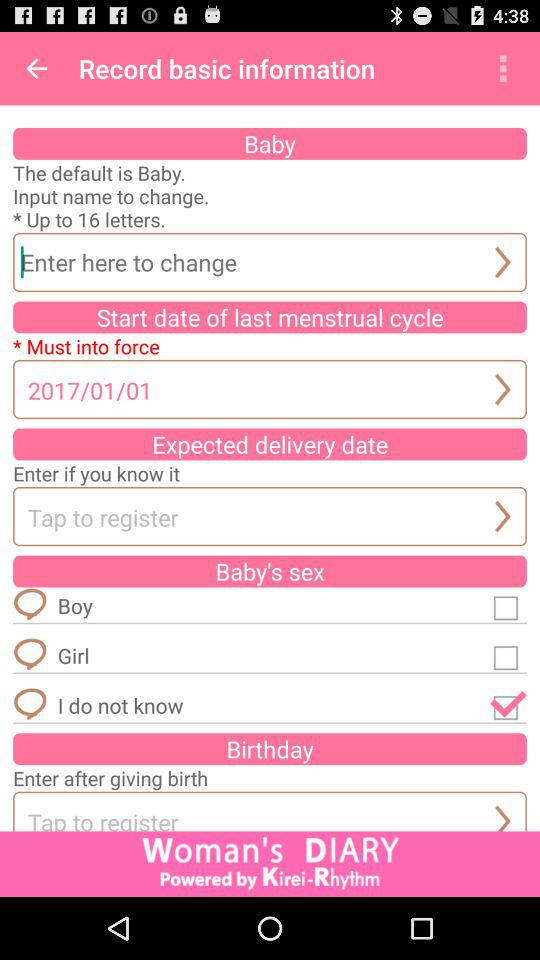What is the selected checkbox for the baby's sex? The selected checkbox is "I do not know". 